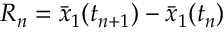Convert formula to latex. <formula><loc_0><loc_0><loc_500><loc_500>R _ { n } = \bar { x } _ { 1 } ( t _ { n + 1 } ) - \bar { x } _ { 1 } ( t _ { n } )</formula> 